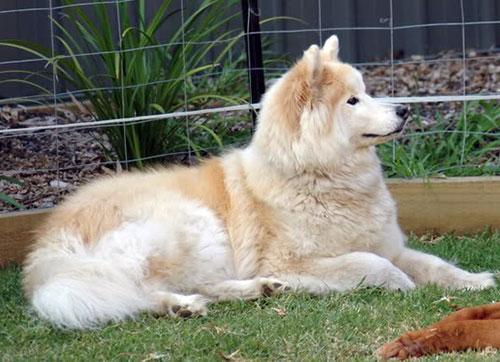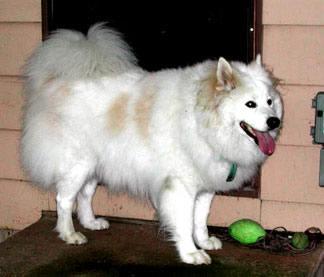The first image is the image on the left, the second image is the image on the right. Given the left and right images, does the statement "An image shows just one fluffy dog standing on grass." hold true? Answer yes or no. No. The first image is the image on the left, the second image is the image on the right. Examine the images to the left and right. Is the description "There is at least one dog facing the camera in the image on the left" accurate? Answer yes or no. No. 